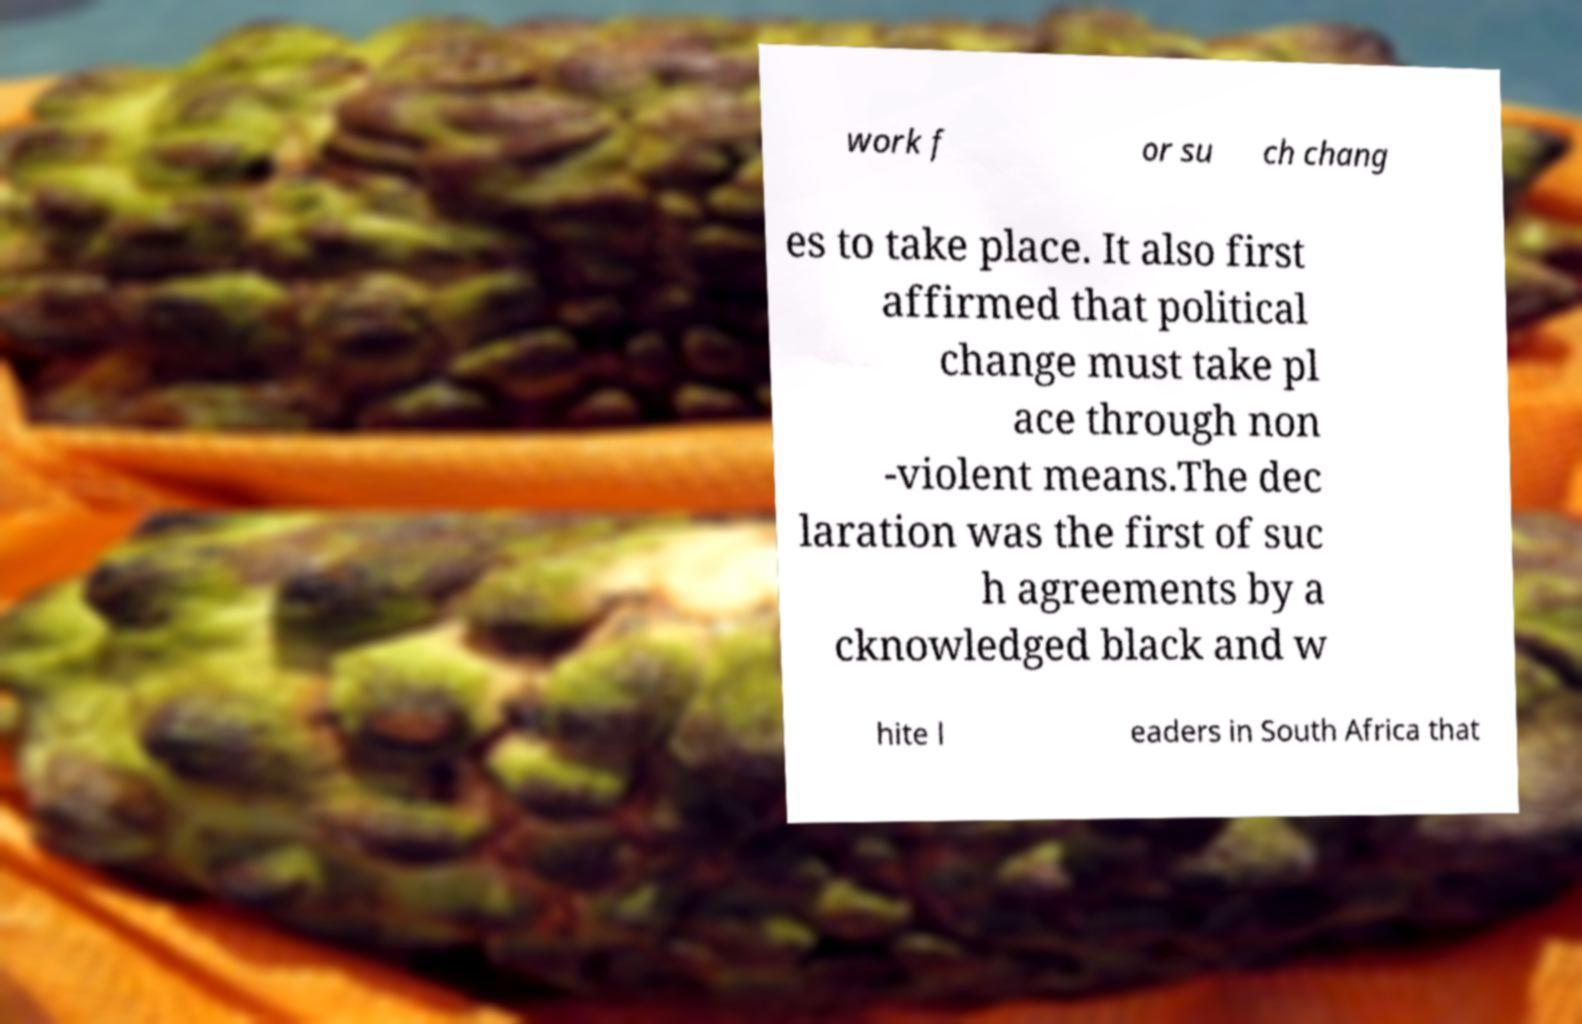What messages or text are displayed in this image? I need them in a readable, typed format. work f or su ch chang es to take place. It also first affirmed that political change must take pl ace through non -violent means.The dec laration was the first of suc h agreements by a cknowledged black and w hite l eaders in South Africa that 